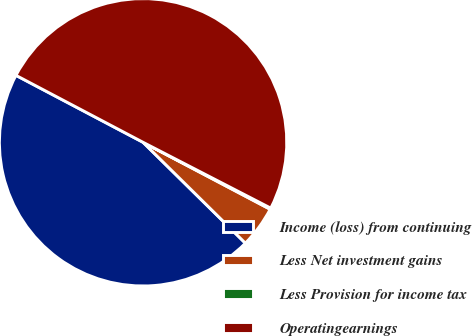Convert chart to OTSL. <chart><loc_0><loc_0><loc_500><loc_500><pie_chart><fcel>Income (loss) from continuing<fcel>Less Net investment gains<fcel>Less Provision for income tax<fcel>Operatingearnings<nl><fcel>45.33%<fcel>4.67%<fcel>0.14%<fcel>49.86%<nl></chart> 